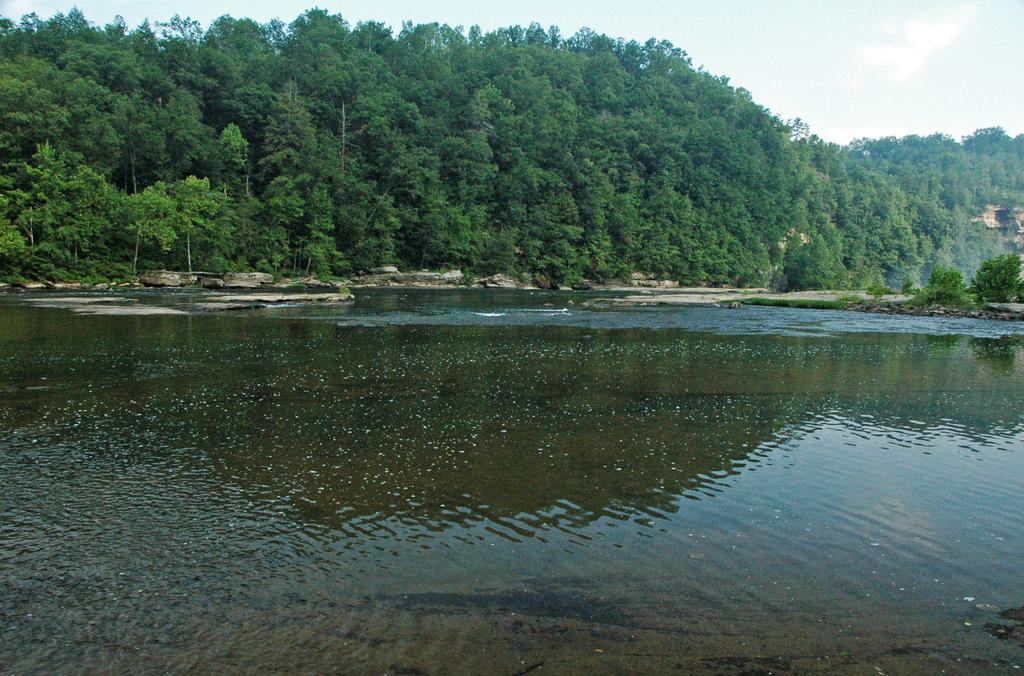What is in the foreground of the image? There is water in the foreground of the image. What can be seen in the background of the image? There are trees and the sky visible in the background of the image. What angle is the science being studied at in the image? There is no reference to science or any angles in the image, as it features water in the foreground and trees and sky in the background. 